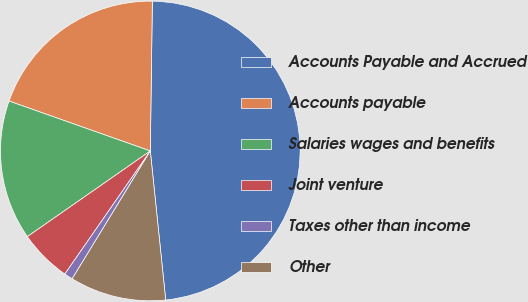Convert chart to OTSL. <chart><loc_0><loc_0><loc_500><loc_500><pie_chart><fcel>Accounts Payable and Accrued<fcel>Accounts payable<fcel>Salaries wages and benefits<fcel>Joint venture<fcel>Taxes other than income<fcel>Other<nl><fcel>48.14%<fcel>19.81%<fcel>15.09%<fcel>5.65%<fcel>0.93%<fcel>10.37%<nl></chart> 